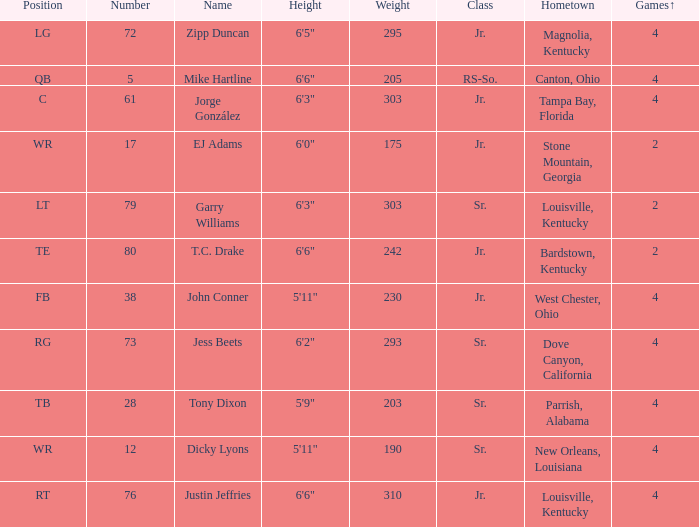Which Class has a Weight of 203? Sr. 